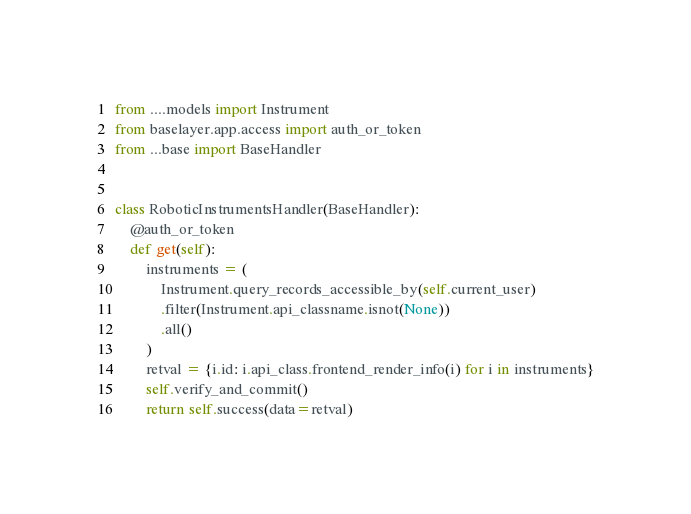<code> <loc_0><loc_0><loc_500><loc_500><_Python_>from ....models import Instrument
from baselayer.app.access import auth_or_token
from ...base import BaseHandler


class RoboticInstrumentsHandler(BaseHandler):
    @auth_or_token
    def get(self):
        instruments = (
            Instrument.query_records_accessible_by(self.current_user)
            .filter(Instrument.api_classname.isnot(None))
            .all()
        )
        retval = {i.id: i.api_class.frontend_render_info(i) for i in instruments}
        self.verify_and_commit()
        return self.success(data=retval)
</code> 